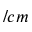Convert formula to latex. <formula><loc_0><loc_0><loc_500><loc_500>/ c m</formula> 